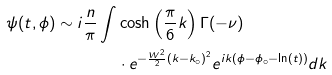Convert formula to latex. <formula><loc_0><loc_0><loc_500><loc_500>\psi ( t , \phi ) \sim i \frac { n } { \pi } \int & \cosh \left ( \frac { \pi } { 6 } k \right ) \Gamma ( - \nu ) \\ & \cdot e ^ { - \frac { W ^ { 2 } } { 2 } ( k - k _ { \circ } ) ^ { 2 } } e ^ { i k ( \phi - \phi _ { \circ } - \ln ( t ) ) } d k</formula> 